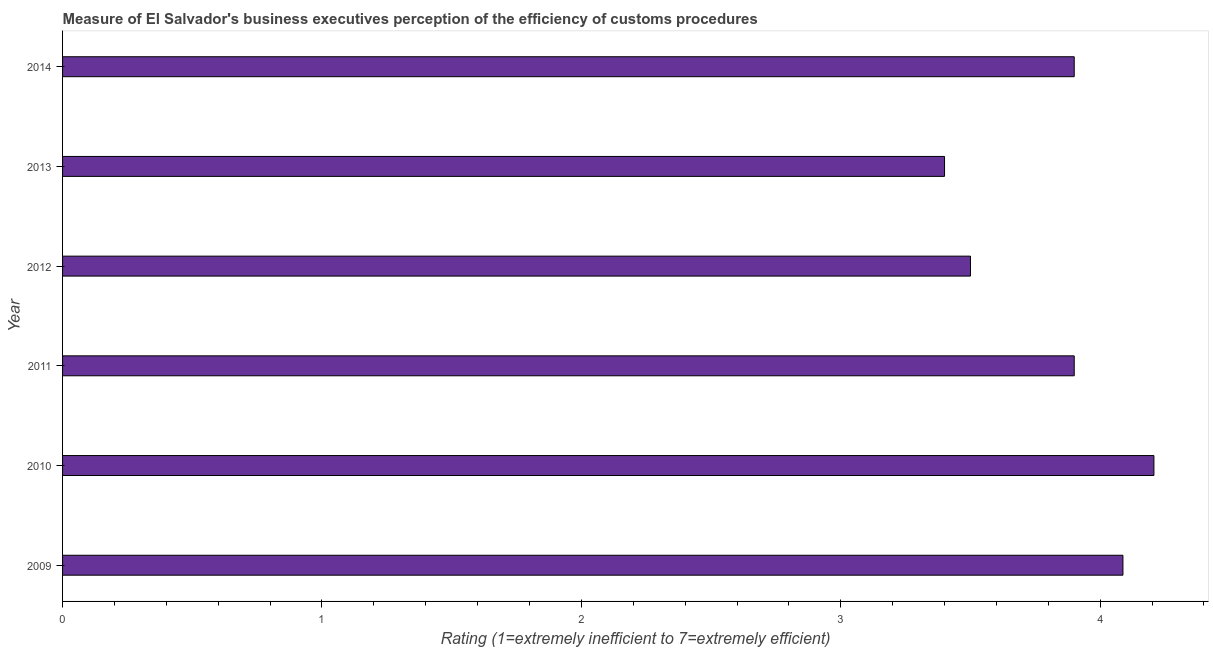What is the title of the graph?
Your answer should be compact. Measure of El Salvador's business executives perception of the efficiency of customs procedures. What is the label or title of the X-axis?
Give a very brief answer. Rating (1=extremely inefficient to 7=extremely efficient). Across all years, what is the maximum rating measuring burden of customs procedure?
Provide a succinct answer. 4.21. Across all years, what is the minimum rating measuring burden of customs procedure?
Provide a succinct answer. 3.4. What is the sum of the rating measuring burden of customs procedure?
Make the answer very short. 23. What is the difference between the rating measuring burden of customs procedure in 2010 and 2012?
Provide a short and direct response. 0.71. What is the average rating measuring burden of customs procedure per year?
Your answer should be very brief. 3.83. Do a majority of the years between 2011 and 2012 (inclusive) have rating measuring burden of customs procedure greater than 3.2 ?
Your answer should be very brief. Yes. What is the ratio of the rating measuring burden of customs procedure in 2011 to that in 2012?
Make the answer very short. 1.11. Is the rating measuring burden of customs procedure in 2011 less than that in 2014?
Give a very brief answer. No. What is the difference between the highest and the second highest rating measuring burden of customs procedure?
Provide a short and direct response. 0.12. Is the sum of the rating measuring burden of customs procedure in 2010 and 2014 greater than the maximum rating measuring burden of customs procedure across all years?
Make the answer very short. Yes. What is the difference between the highest and the lowest rating measuring burden of customs procedure?
Your response must be concise. 0.81. How many bars are there?
Provide a succinct answer. 6. What is the Rating (1=extremely inefficient to 7=extremely efficient) of 2009?
Make the answer very short. 4.09. What is the Rating (1=extremely inefficient to 7=extremely efficient) in 2010?
Offer a very short reply. 4.21. What is the Rating (1=extremely inefficient to 7=extremely efficient) of 2011?
Offer a terse response. 3.9. What is the Rating (1=extremely inefficient to 7=extremely efficient) of 2012?
Provide a succinct answer. 3.5. What is the Rating (1=extremely inefficient to 7=extremely efficient) in 2014?
Your answer should be very brief. 3.9. What is the difference between the Rating (1=extremely inefficient to 7=extremely efficient) in 2009 and 2010?
Provide a short and direct response. -0.12. What is the difference between the Rating (1=extremely inefficient to 7=extremely efficient) in 2009 and 2011?
Your answer should be very brief. 0.19. What is the difference between the Rating (1=extremely inefficient to 7=extremely efficient) in 2009 and 2012?
Offer a terse response. 0.59. What is the difference between the Rating (1=extremely inefficient to 7=extremely efficient) in 2009 and 2013?
Give a very brief answer. 0.69. What is the difference between the Rating (1=extremely inefficient to 7=extremely efficient) in 2009 and 2014?
Your answer should be very brief. 0.19. What is the difference between the Rating (1=extremely inefficient to 7=extremely efficient) in 2010 and 2011?
Ensure brevity in your answer.  0.31. What is the difference between the Rating (1=extremely inefficient to 7=extremely efficient) in 2010 and 2012?
Keep it short and to the point. 0.71. What is the difference between the Rating (1=extremely inefficient to 7=extremely efficient) in 2010 and 2013?
Offer a very short reply. 0.81. What is the difference between the Rating (1=extremely inefficient to 7=extremely efficient) in 2010 and 2014?
Offer a very short reply. 0.31. What is the difference between the Rating (1=extremely inefficient to 7=extremely efficient) in 2011 and 2012?
Keep it short and to the point. 0.4. What is the difference between the Rating (1=extremely inefficient to 7=extremely efficient) in 2012 and 2014?
Keep it short and to the point. -0.4. What is the ratio of the Rating (1=extremely inefficient to 7=extremely efficient) in 2009 to that in 2010?
Ensure brevity in your answer.  0.97. What is the ratio of the Rating (1=extremely inefficient to 7=extremely efficient) in 2009 to that in 2011?
Your answer should be compact. 1.05. What is the ratio of the Rating (1=extremely inefficient to 7=extremely efficient) in 2009 to that in 2012?
Provide a short and direct response. 1.17. What is the ratio of the Rating (1=extremely inefficient to 7=extremely efficient) in 2009 to that in 2013?
Offer a terse response. 1.2. What is the ratio of the Rating (1=extremely inefficient to 7=extremely efficient) in 2009 to that in 2014?
Your response must be concise. 1.05. What is the ratio of the Rating (1=extremely inefficient to 7=extremely efficient) in 2010 to that in 2011?
Your response must be concise. 1.08. What is the ratio of the Rating (1=extremely inefficient to 7=extremely efficient) in 2010 to that in 2012?
Your response must be concise. 1.2. What is the ratio of the Rating (1=extremely inefficient to 7=extremely efficient) in 2010 to that in 2013?
Offer a terse response. 1.24. What is the ratio of the Rating (1=extremely inefficient to 7=extremely efficient) in 2010 to that in 2014?
Provide a short and direct response. 1.08. What is the ratio of the Rating (1=extremely inefficient to 7=extremely efficient) in 2011 to that in 2012?
Provide a succinct answer. 1.11. What is the ratio of the Rating (1=extremely inefficient to 7=extremely efficient) in 2011 to that in 2013?
Make the answer very short. 1.15. What is the ratio of the Rating (1=extremely inefficient to 7=extremely efficient) in 2011 to that in 2014?
Provide a succinct answer. 1. What is the ratio of the Rating (1=extremely inefficient to 7=extremely efficient) in 2012 to that in 2014?
Your response must be concise. 0.9. What is the ratio of the Rating (1=extremely inefficient to 7=extremely efficient) in 2013 to that in 2014?
Make the answer very short. 0.87. 